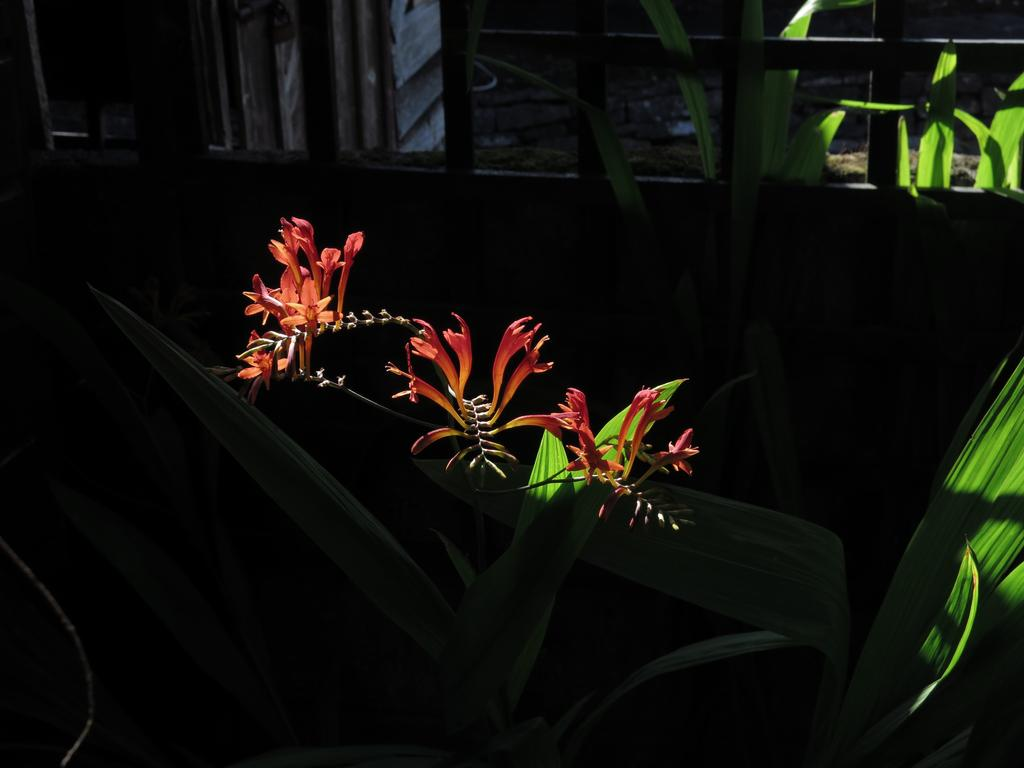What types of living organisms can be seen in the image? Plants and flowers are visible in the image. What is the background of the image made of? There is a wall visible in the image. What is the surface on which the plants and flowers are situated? The ground is visible in the image. How many beans are present in the image? There are no beans visible in the image. What part of the plants can be seen flying in the image? There are no parts of the plants flying in the image. 